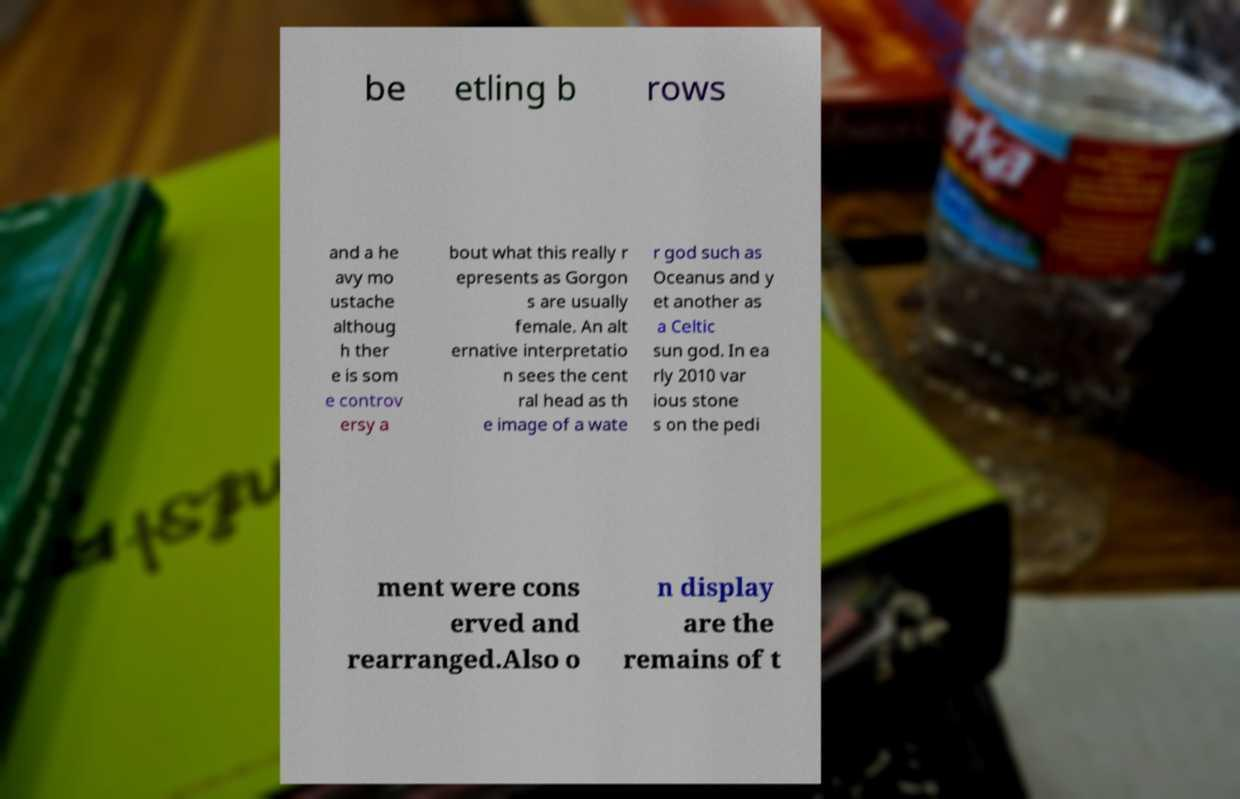Can you accurately transcribe the text from the provided image for me? be etling b rows and a he avy mo ustache althoug h ther e is som e controv ersy a bout what this really r epresents as Gorgon s are usually female. An alt ernative interpretatio n sees the cent ral head as th e image of a wate r god such as Oceanus and y et another as a Celtic sun god. In ea rly 2010 var ious stone s on the pedi ment were cons erved and rearranged.Also o n display are the remains of t 